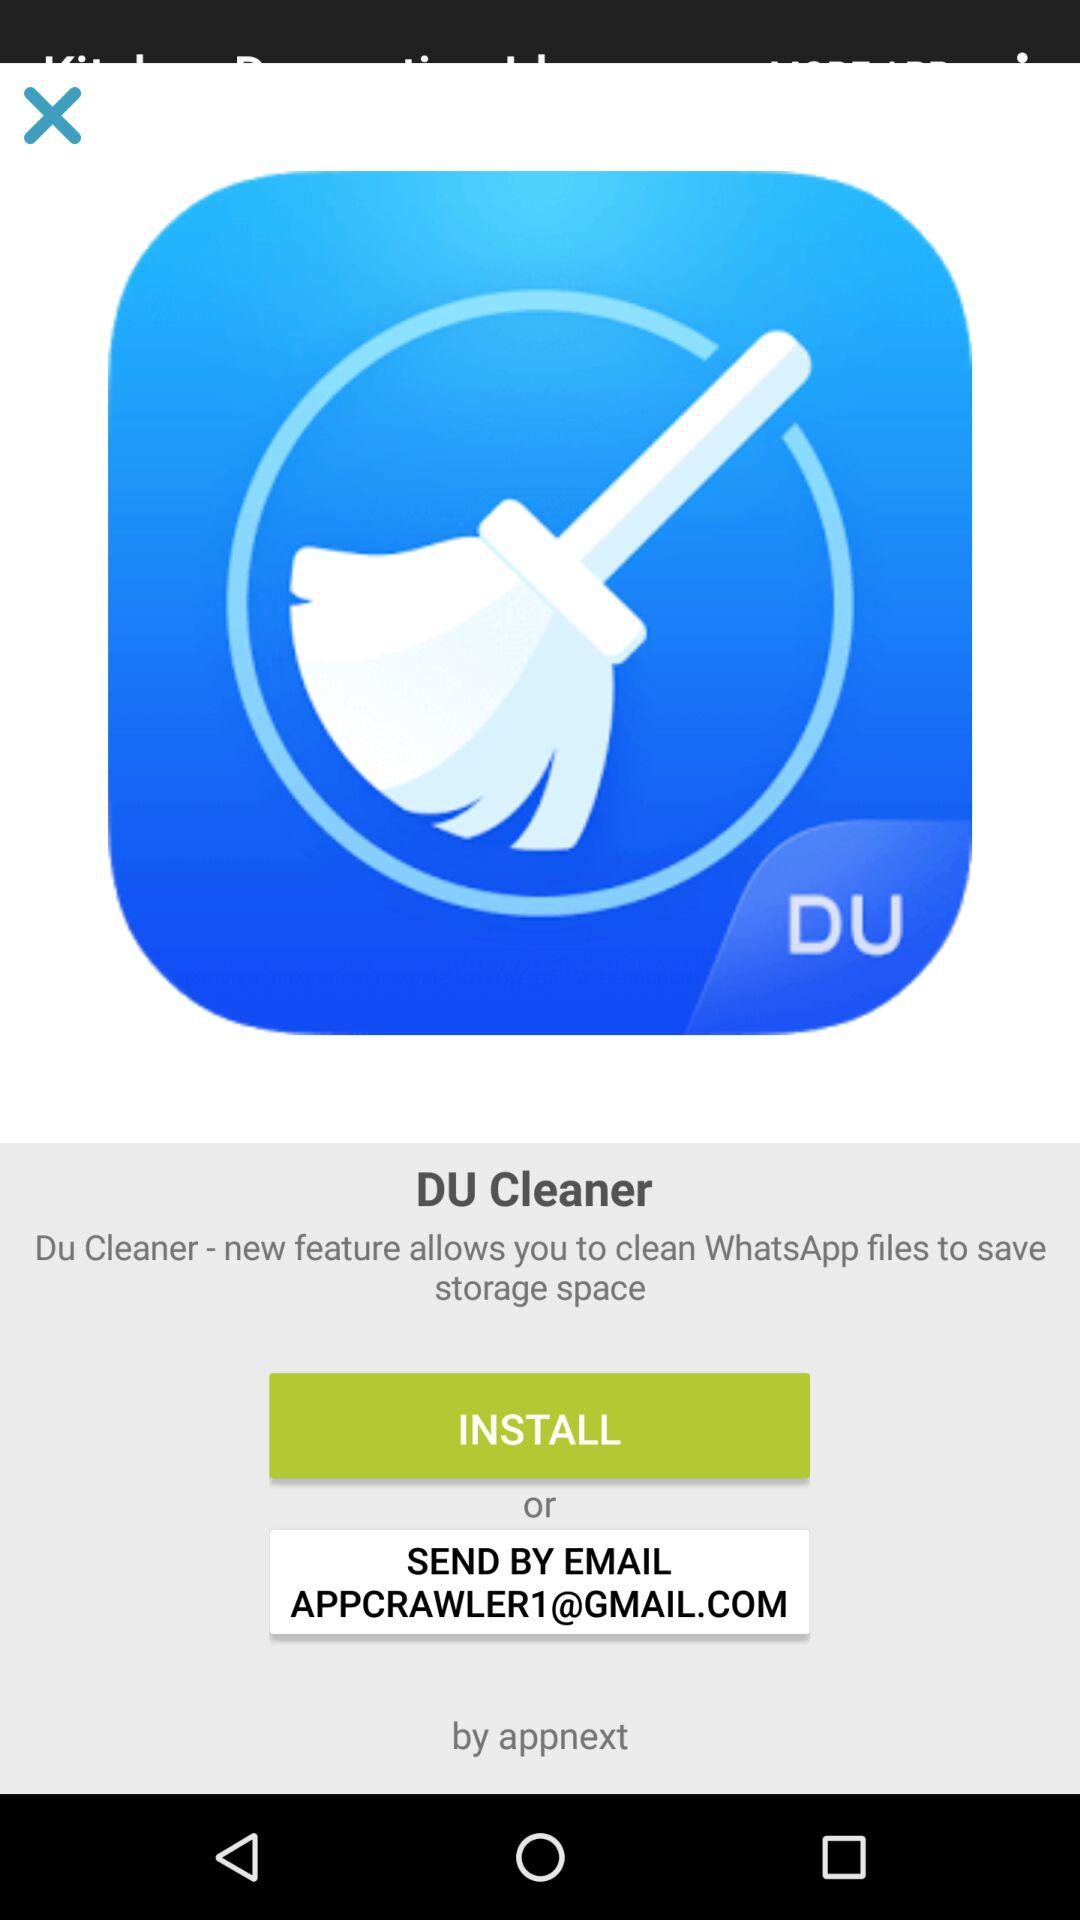What is the app name? The app name is "DU Cleaner". 